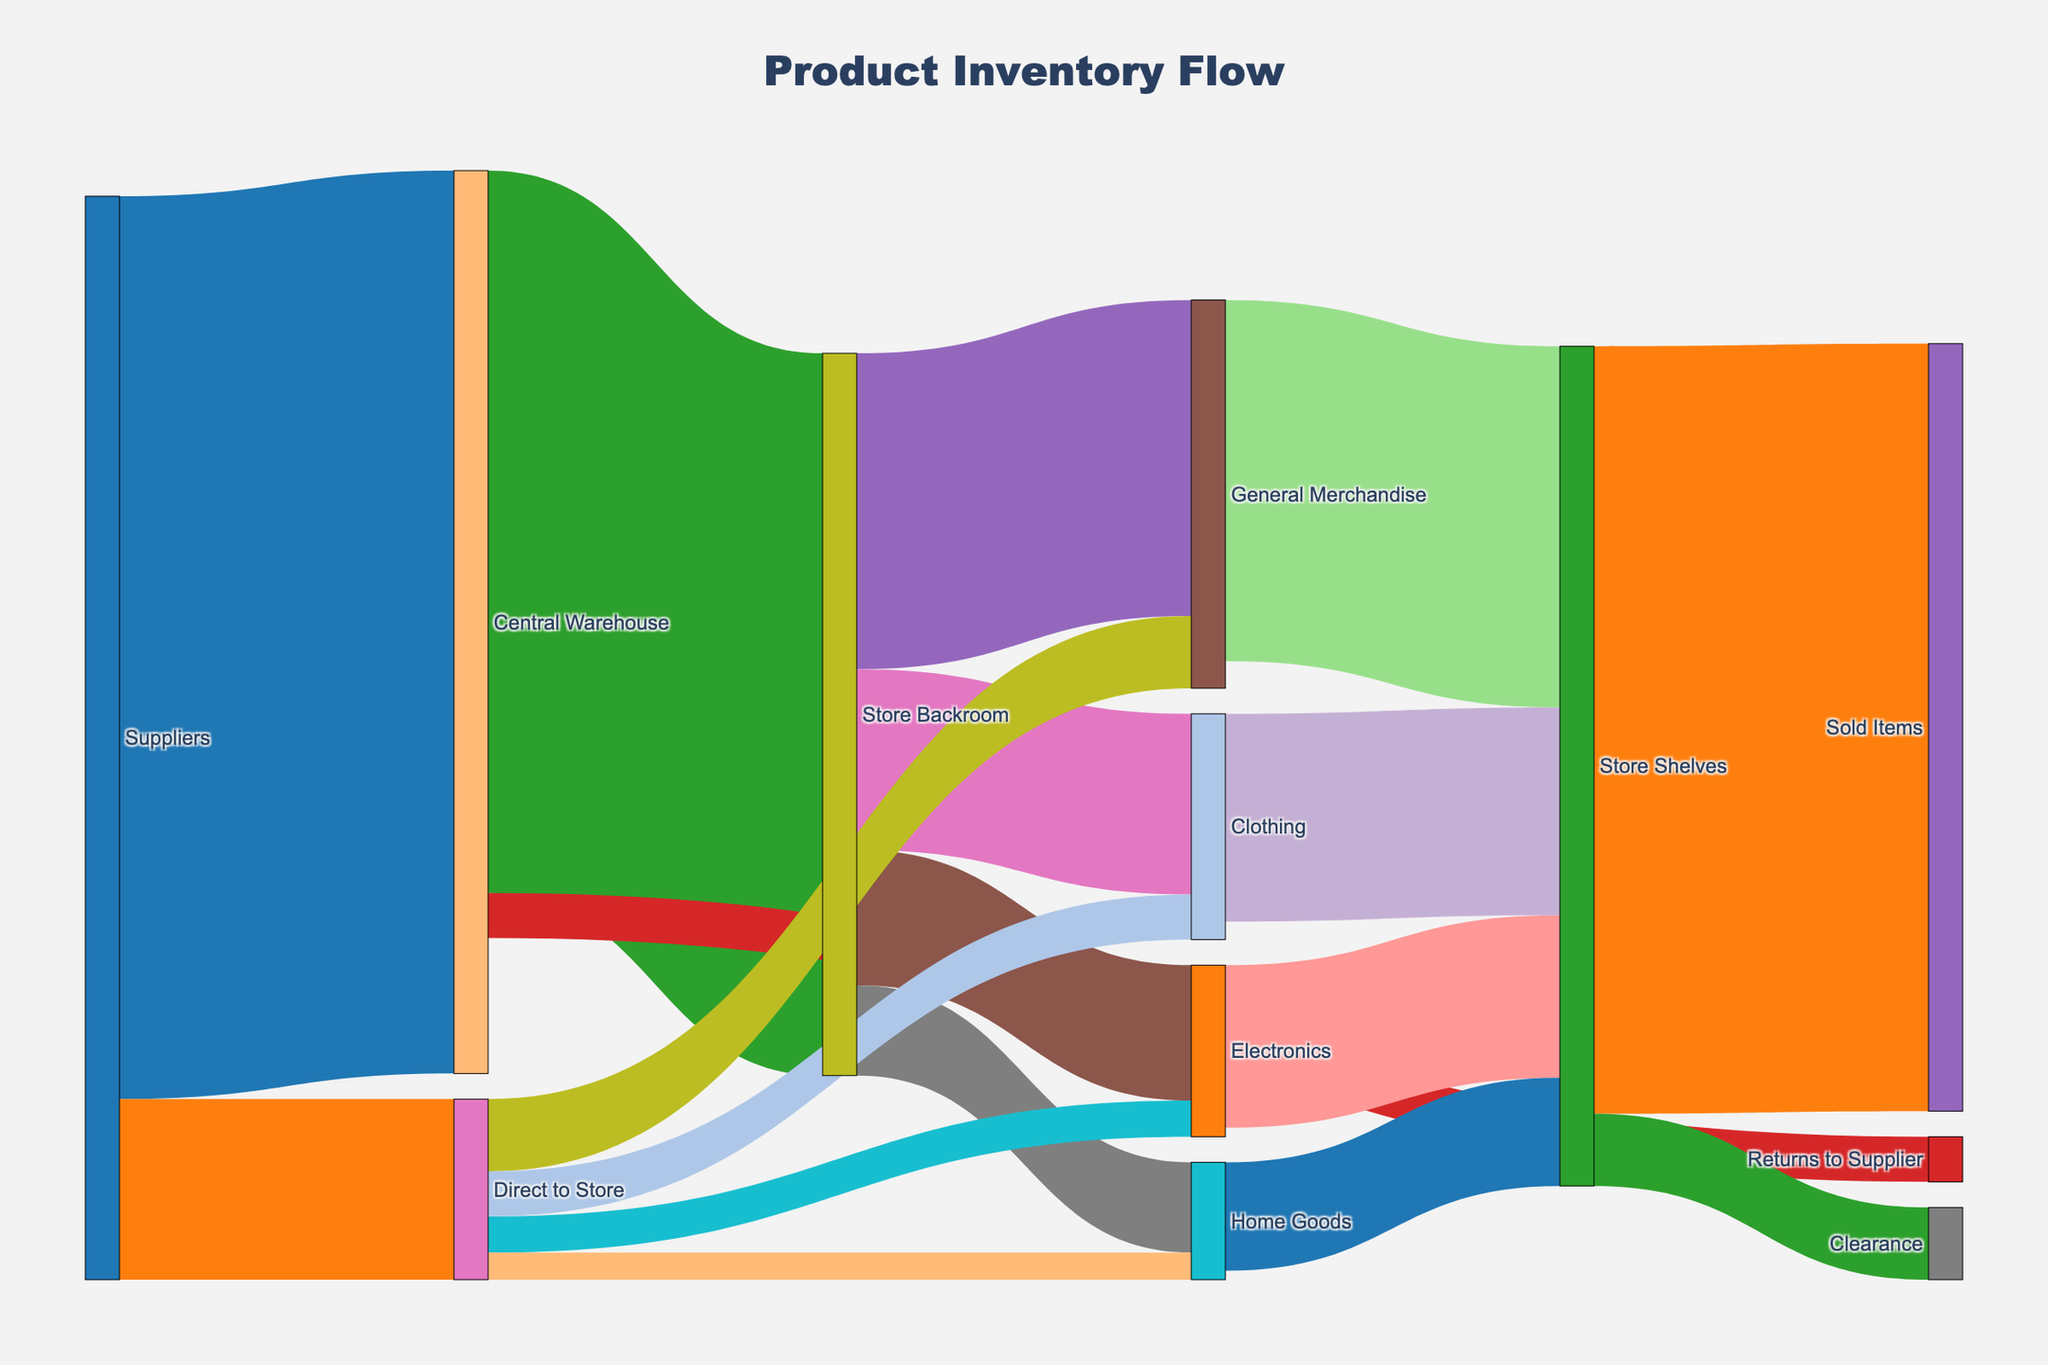What is the total amount of products received by the Central Warehouse from the suppliers? The Sankey Diagram shows that 10,000 units flow from the suppliers to the Central Warehouse.
Answer: 10,000 Which path has the highest flow of products from the backroom to a specific product category? By observing the flows from the 'Store Backroom', you can see that 'General Merchandise' has the highest flow with 3,500 units.
Answer: General Merchandise How many products are returned to the supplier from the Central Warehouse? The diagram shows a flow of 500 units returning from the Central Warehouse to suppliers.
Answer: 500 What is the total amount of products that go directly to store shelves? To calculate this, you add up the flows from 'Direct to Store' to all categories: 800 (General Merchandise) + 400 (Electronics) + 500 (Clothing) + 300 (Home Goods) = 2,000 units.
Answer: 2,000 How many total products are stored in the 'Store Backroom'? Products stored in the 'Store Backroom' are those sent from the Central Warehouse. The amount is shown as 8,000 units.
Answer: 8,000 What is the combined number of products in 'General Merchandise' and 'Electronics' categories sent from 'Direct to Store'? Adding the units from 'Direct to Store' to both categories: 800 (General Merchandise) + 400 (Electronics) = 1,200 units.
Answer: 1,200 Which category, 'Clothing' or 'Electronics', has the higher quantity ending up on store shelves? The diagram indicates 'Clothing' ends up with 2,300 units on store shelves, while 'Electronics' has 1,800 units.
Answer: Clothing What is the ratio of products ending up in 'Sold Items' to those in 'Clearance'? The diagram shows 8,500 units in 'Sold Items' and 800 units in 'Clearance'. The ratio is 8500:800, which simplifies to 10.625:1.
Answer: 10.625:1 What is the total amount of products supplied directly to stores and through the Central Warehouse combined? Total products from suppliers: 10,000 (Central Warehouse) + 2,000 (Direct to Store) = 12,000 units.
Answer: 12,000 Which flow shows a smaller number: products sent from the warehouse to be returned to suppliers or products in the 'Home Goods' category on store shelves? The flow of returns to the supplier is 500 units, while 'Home Goods' shows 1,200 units on store shelves. Therefore, returns have a smaller number.
Answer: Returns to suppliers 